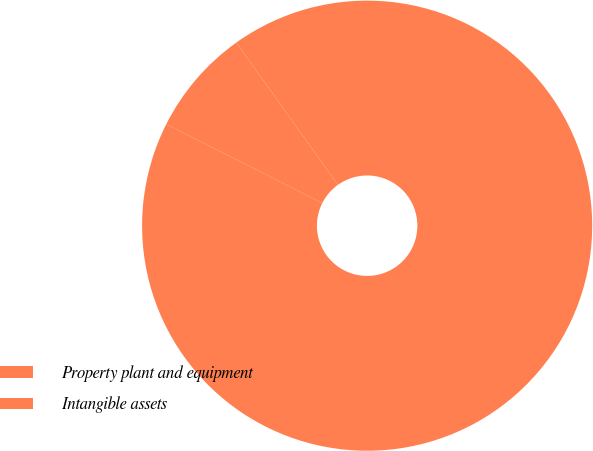Convert chart to OTSL. <chart><loc_0><loc_0><loc_500><loc_500><pie_chart><fcel>Property plant and equipment<fcel>Intangible assets<nl><fcel>92.31%<fcel>7.69%<nl></chart> 